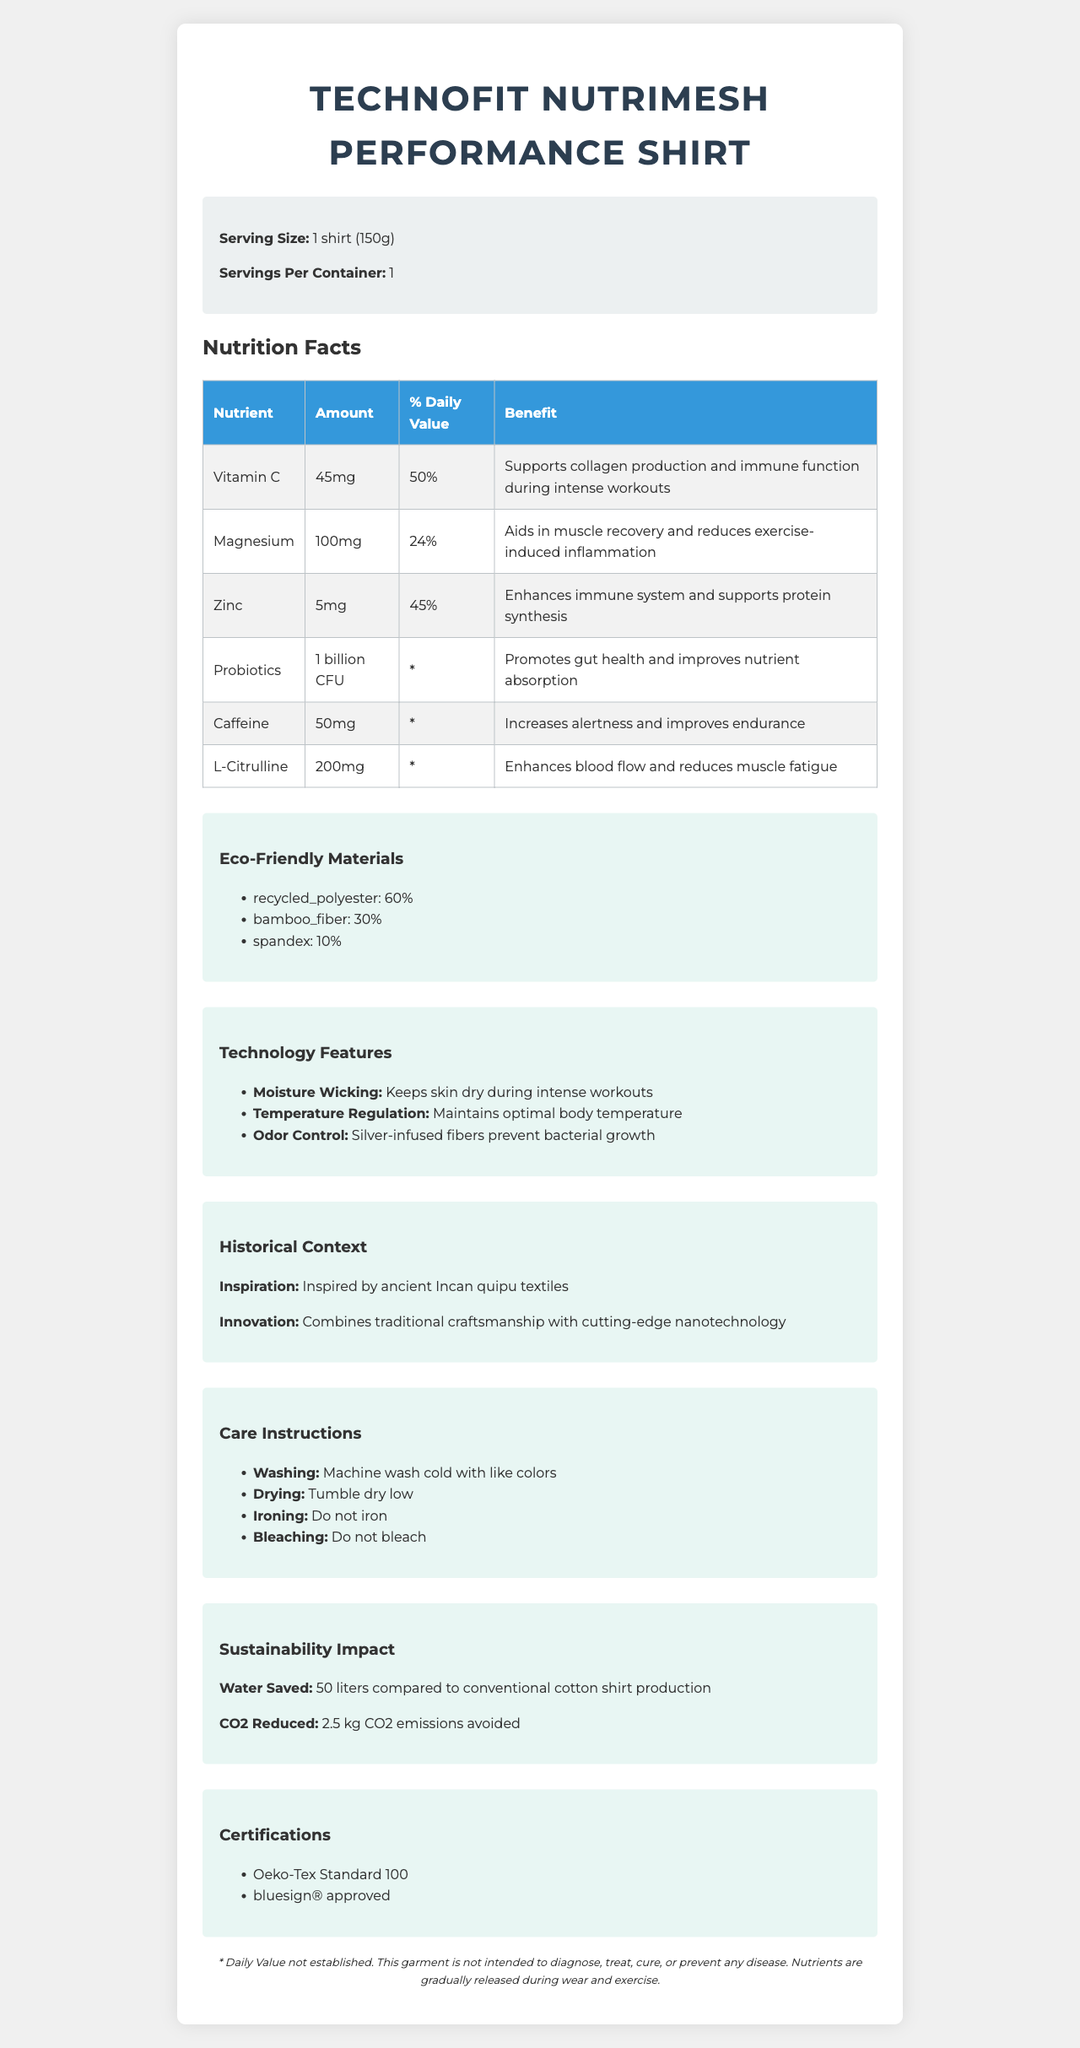what is the serving size of the TechnoFit NutriMesh Performance Shirt? The serving size is clearly stated as "1 shirt (150g)" in the product information section.
Answer: 1 shirt (150g) What is the % Daily Value of Vitamin C provided by the shirt? The document states that Vitamin C has a daily value of 50%.
Answer: 50% What ancient culture inspired the design of this shirt? The historical context section mentions that the shirt was inspired by ancient Incan quipu textiles.
Answer: Incan List the performance-enhancing components infused in the shirt. The performance-enhancing components listed in the document are caffeine and L-citrulline.
Answer: Caffeine and L-Citrulline What is one of the benefits of zinc in the shirt? The benefit of zinc is specified as enhancing the immune system and supporting protein synthesis.
Answer: Enhances immune system and supports protein synthesis Which material makes up the largest percentage of the shirt’s fabric? A. Bamboo Fiber B. Spandex C. Recycled Polyester D. Cotton The eco-friendly materials section shows Recycled Polyester at 60%, which is the largest percentage.
Answer: C. Recycled Polyester What is the amount of caffeine in the shirt? A. 50mg B. 100mg C. 5mg D. 200mg The amount of caffeine listed in the performance-enhancing components section is 50mg.
Answer: A. 50mg Is the TechnoFit NutriMesh Performance Shirt machine washable? The care instructions section states that it is machine wash cold with like colors.
Answer: Yes Summarize the main idea of the document. The document gives a comprehensive overview of the product, emphasizing its innovative features, health benefits, eco-friendly composition, and care guidelines.
Answer: The document provides a detailed description of the TechnoFit NutriMesh Performance Shirt, highlighting its nutrient infusion, performance-enhancing components, eco-friendly materials, technology features, historical inspiration, care instructions, sustainability impact, and certifications. Does the shirt contribute to reducing CO2 emissions? The sustainability impact section states that 2.5 kg of CO2 emissions are avoided.
Answer: Yes What is the recommended drying method for the shirt? The care instructions section advises to "tumble dry low".
Answer: Tumble dry low Does the information document contain a phone number for customer service? The provided description does not mention any phone number or contact details for customer service.
Answer: Not enough information 